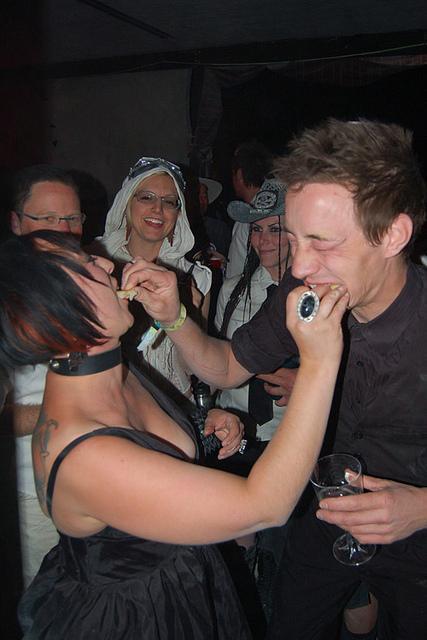How many people can you see?
Give a very brief answer. 6. How many birds are standing in the water?
Give a very brief answer. 0. 